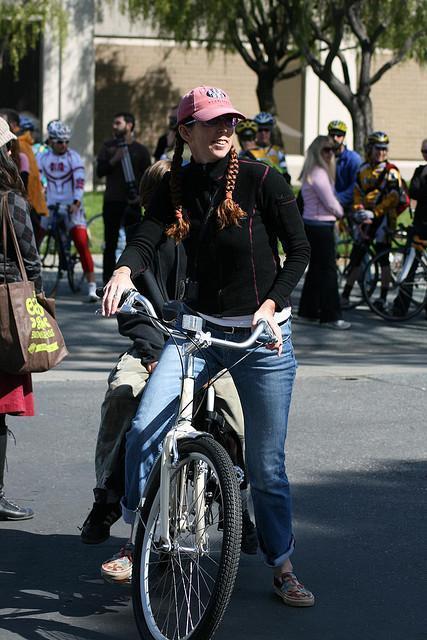How many people can you see?
Give a very brief answer. 8. How many bicycles are in the picture?
Give a very brief answer. 3. 